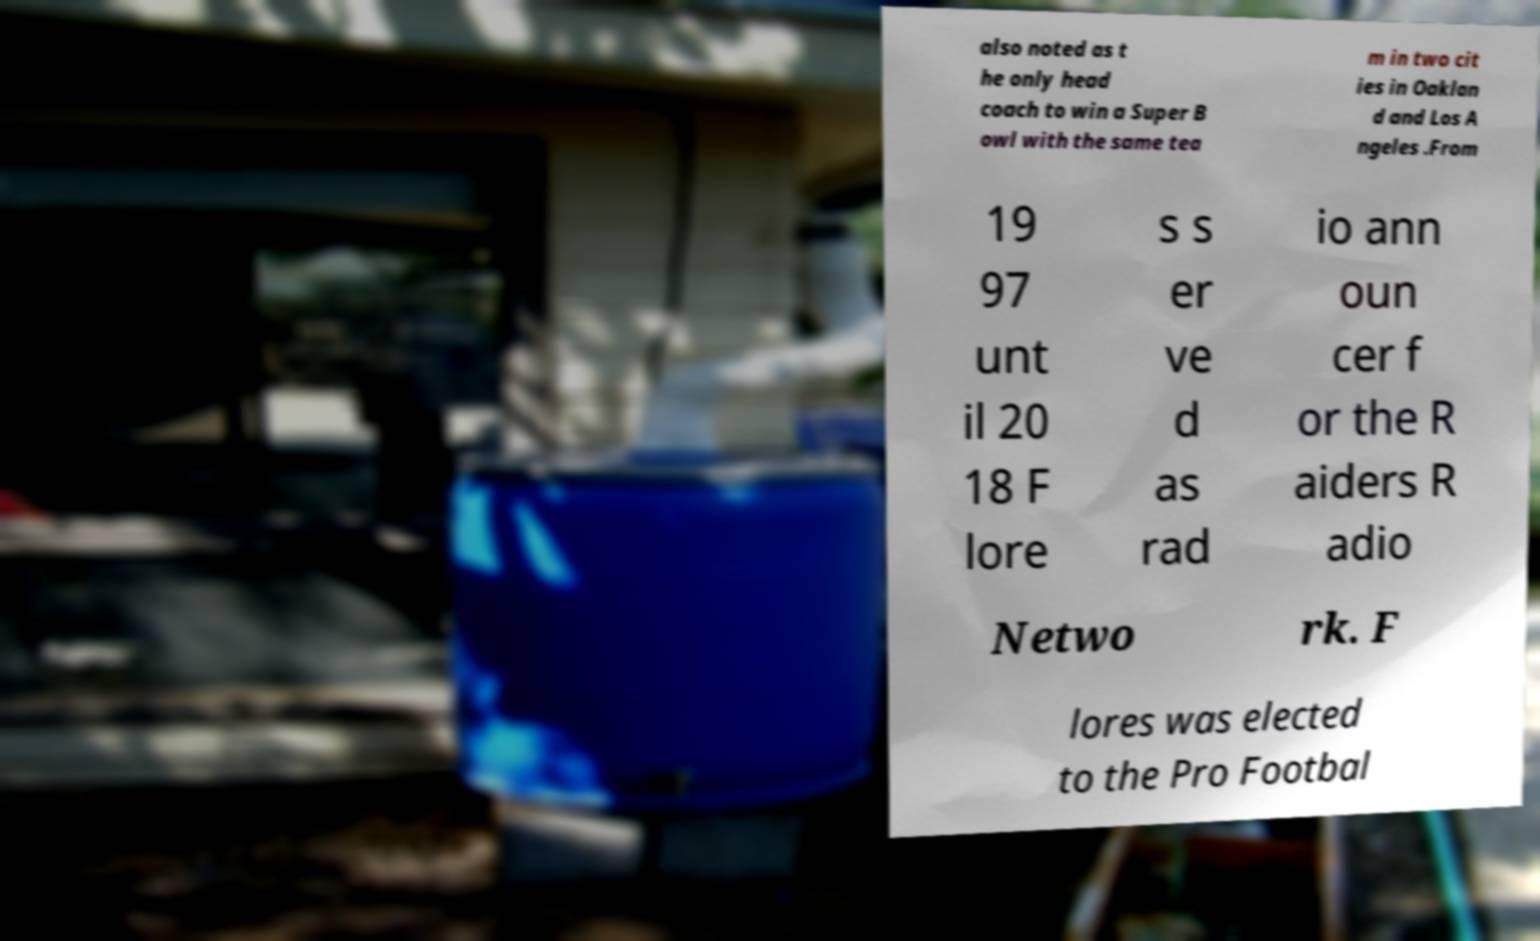Can you read and provide the text displayed in the image?This photo seems to have some interesting text. Can you extract and type it out for me? also noted as t he only head coach to win a Super B owl with the same tea m in two cit ies in Oaklan d and Los A ngeles .From 19 97 unt il 20 18 F lore s s er ve d as rad io ann oun cer f or the R aiders R adio Netwo rk. F lores was elected to the Pro Footbal 